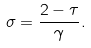Convert formula to latex. <formula><loc_0><loc_0><loc_500><loc_500>\sigma = \frac { 2 - \tau } { \gamma } .</formula> 